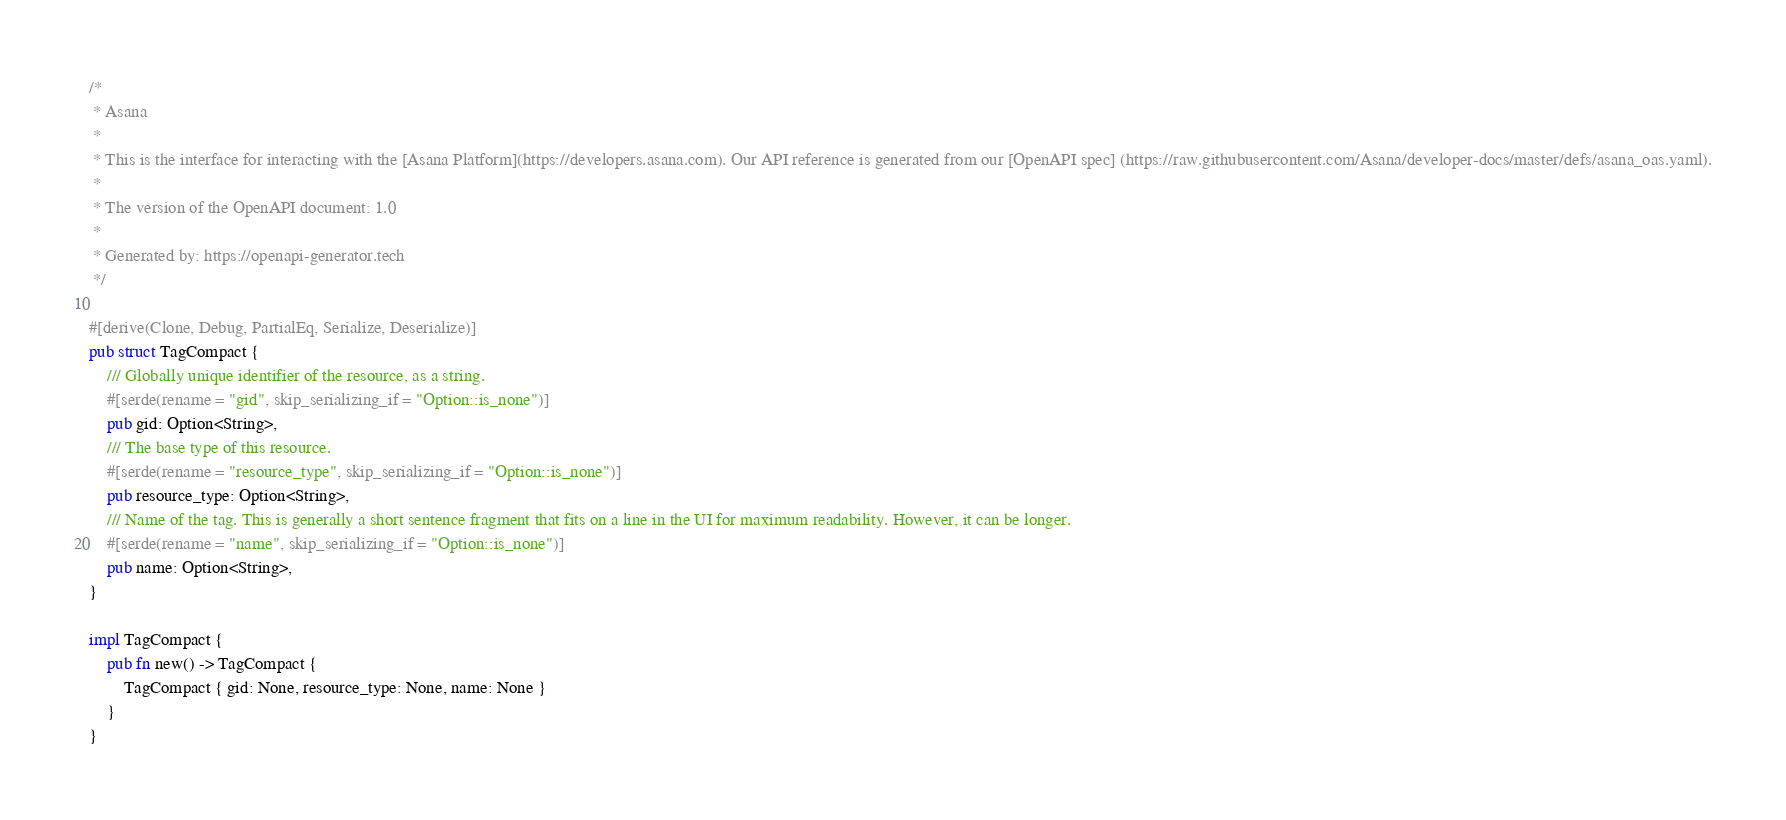<code> <loc_0><loc_0><loc_500><loc_500><_Rust_>/*
 * Asana
 *
 * This is the interface for interacting with the [Asana Platform](https://developers.asana.com). Our API reference is generated from our [OpenAPI spec] (https://raw.githubusercontent.com/Asana/developer-docs/master/defs/asana_oas.yaml).
 *
 * The version of the OpenAPI document: 1.0
 *
 * Generated by: https://openapi-generator.tech
 */

#[derive(Clone, Debug, PartialEq, Serialize, Deserialize)]
pub struct TagCompact {
    /// Globally unique identifier of the resource, as a string.
    #[serde(rename = "gid", skip_serializing_if = "Option::is_none")]
    pub gid: Option<String>,
    /// The base type of this resource.
    #[serde(rename = "resource_type", skip_serializing_if = "Option::is_none")]
    pub resource_type: Option<String>,
    /// Name of the tag. This is generally a short sentence fragment that fits on a line in the UI for maximum readability. However, it can be longer.
    #[serde(rename = "name", skip_serializing_if = "Option::is_none")]
    pub name: Option<String>,
}

impl TagCompact {
    pub fn new() -> TagCompact {
        TagCompact { gid: None, resource_type: None, name: None }
    }
}
</code> 